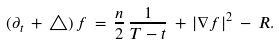<formula> <loc_0><loc_0><loc_500><loc_500>( \partial _ { t } \, + \, \triangle ) \, f \, = \, \frac { n } { 2 } \, \frac { 1 } { T - t } \, + \, | \nabla f | ^ { 2 } \, - \, R .</formula> 